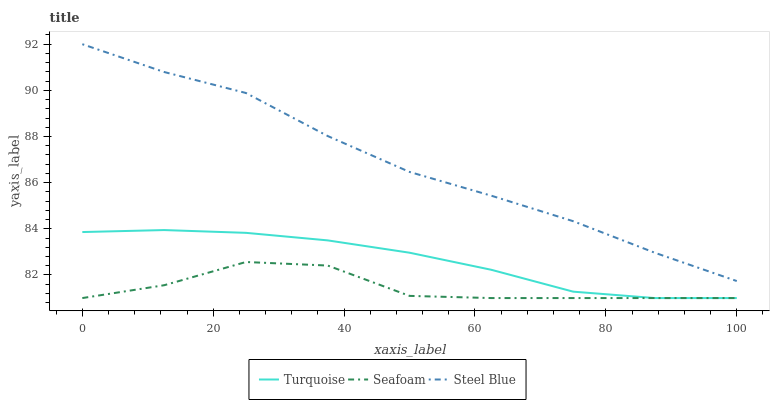Does Seafoam have the minimum area under the curve?
Answer yes or no. Yes. Does Steel Blue have the maximum area under the curve?
Answer yes or no. Yes. Does Steel Blue have the minimum area under the curve?
Answer yes or no. No. Does Seafoam have the maximum area under the curve?
Answer yes or no. No. Is Turquoise the smoothest?
Answer yes or no. Yes. Is Seafoam the roughest?
Answer yes or no. Yes. Is Steel Blue the smoothest?
Answer yes or no. No. Is Steel Blue the roughest?
Answer yes or no. No. Does Steel Blue have the lowest value?
Answer yes or no. No. Does Steel Blue have the highest value?
Answer yes or no. Yes. Does Seafoam have the highest value?
Answer yes or no. No. Is Turquoise less than Steel Blue?
Answer yes or no. Yes. Is Steel Blue greater than Seafoam?
Answer yes or no. Yes. Does Turquoise intersect Steel Blue?
Answer yes or no. No. 